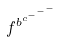Convert formula to latex. <formula><loc_0><loc_0><loc_500><loc_500>f ^ { b ^ { c ^ { - ^ { - ^ { - } } } } }</formula> 